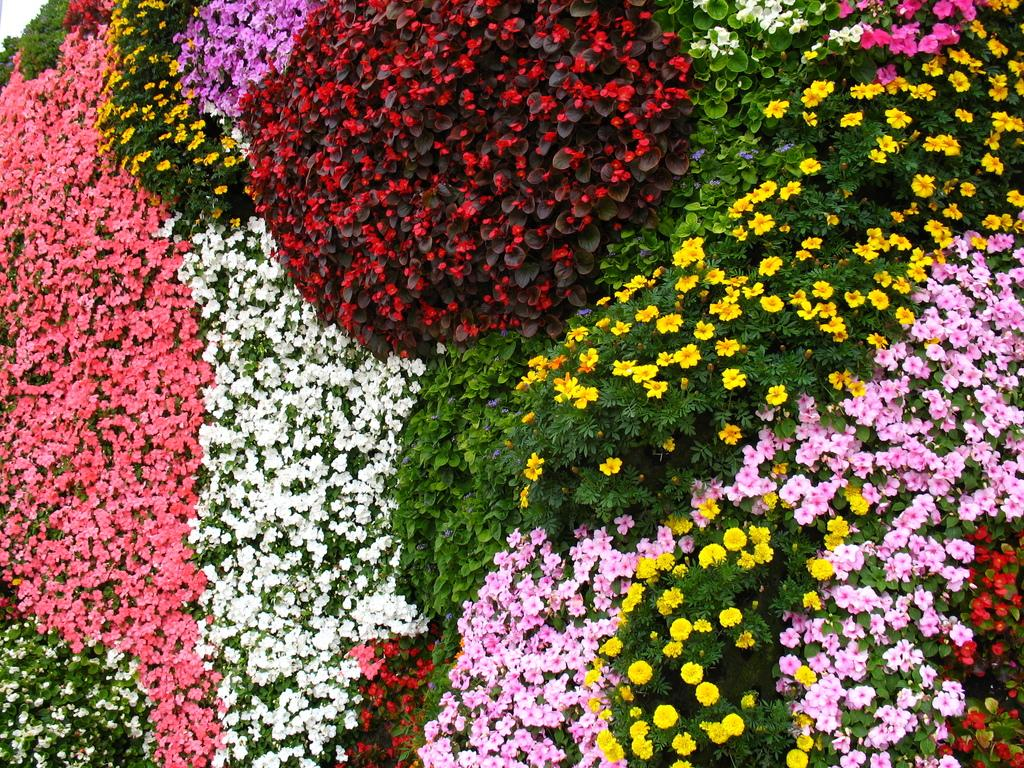What is present in the image? There are flowers in the image. Where are the flowers located? The flowers are on plants. What can be observed about the colors of the flowers? The flowers are of different colors. What type of agreement is being discussed in the image? There is no discussion or agreement present in the image; it features flowers on plants with different colors. 